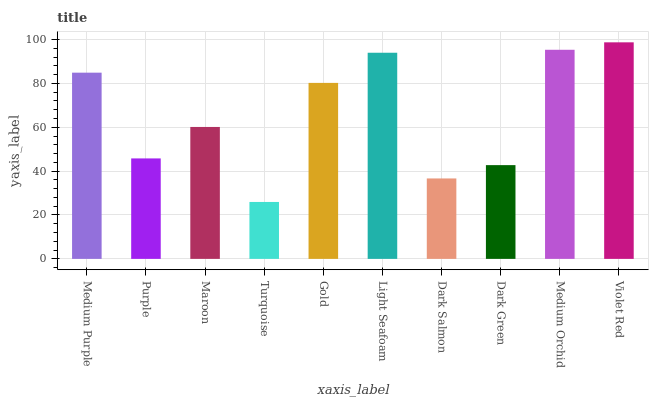Is Purple the minimum?
Answer yes or no. No. Is Purple the maximum?
Answer yes or no. No. Is Medium Purple greater than Purple?
Answer yes or no. Yes. Is Purple less than Medium Purple?
Answer yes or no. Yes. Is Purple greater than Medium Purple?
Answer yes or no. No. Is Medium Purple less than Purple?
Answer yes or no. No. Is Gold the high median?
Answer yes or no. Yes. Is Maroon the low median?
Answer yes or no. Yes. Is Light Seafoam the high median?
Answer yes or no. No. Is Purple the low median?
Answer yes or no. No. 